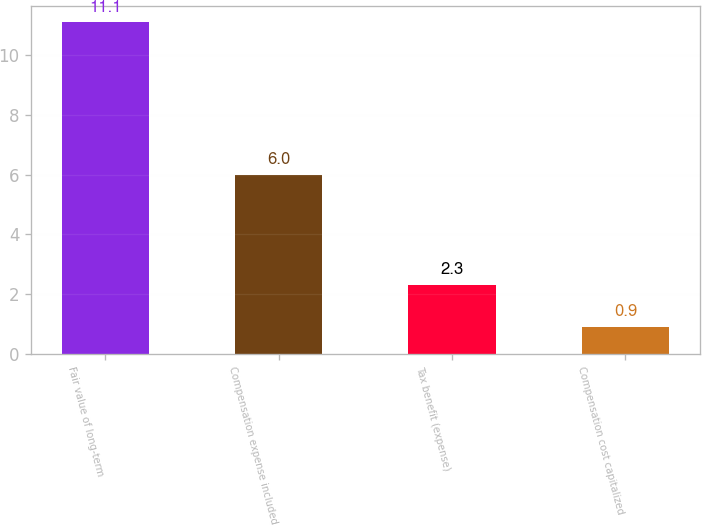Convert chart. <chart><loc_0><loc_0><loc_500><loc_500><bar_chart><fcel>Fair value of long-term<fcel>Compensation expense included<fcel>Tax benefit (expense)<fcel>Compensation cost capitalized<nl><fcel>11.1<fcel>6<fcel>2.3<fcel>0.9<nl></chart> 